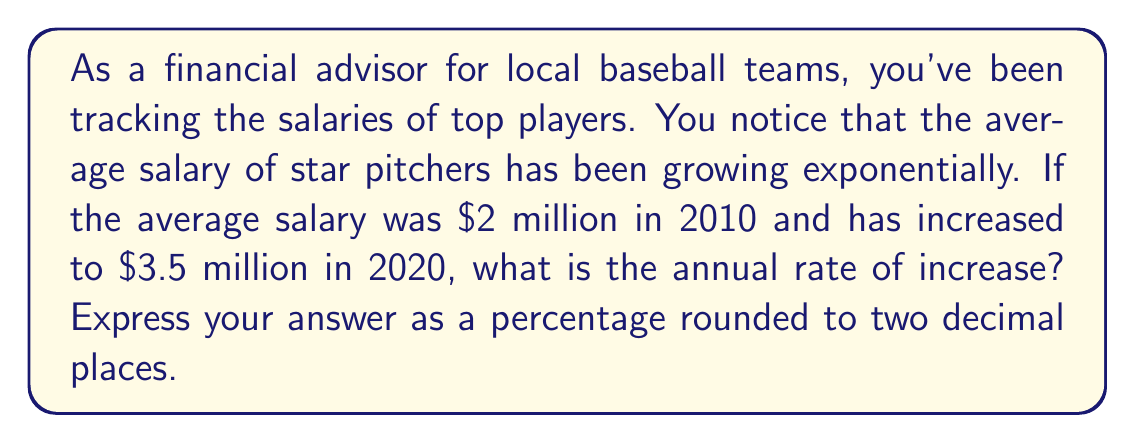Solve this math problem. To solve this problem, we'll use the exponential growth formula:

$$ A = P(1 + r)^t $$

Where:
$A$ is the final amount
$P$ is the initial amount
$r$ is the annual rate of increase (as a decimal)
$t$ is the time in years

Given:
$P = \$2$ million (initial salary in 2010)
$A = \$3.5$ million (final salary in 2020)
$t = 10$ years (from 2010 to 2020)

Let's substitute these values into the formula:

$$ 3.5 = 2(1 + r)^{10} $$

Now, we need to solve for $r$:

1) Divide both sides by 2:
   $$ 1.75 = (1 + r)^{10} $$

2) Take the 10th root of both sides:
   $$ \sqrt[10]{1.75} = 1 + r $$

3) Subtract 1 from both sides:
   $$ \sqrt[10]{1.75} - 1 = r $$

4) Calculate the value:
   $$ r \approx 0.0574 $$

5) Convert to a percentage:
   $$ 0.0574 \times 100\% = 5.74\% $$

Therefore, the annual rate of increase is approximately 5.74%.
Answer: 5.74% 